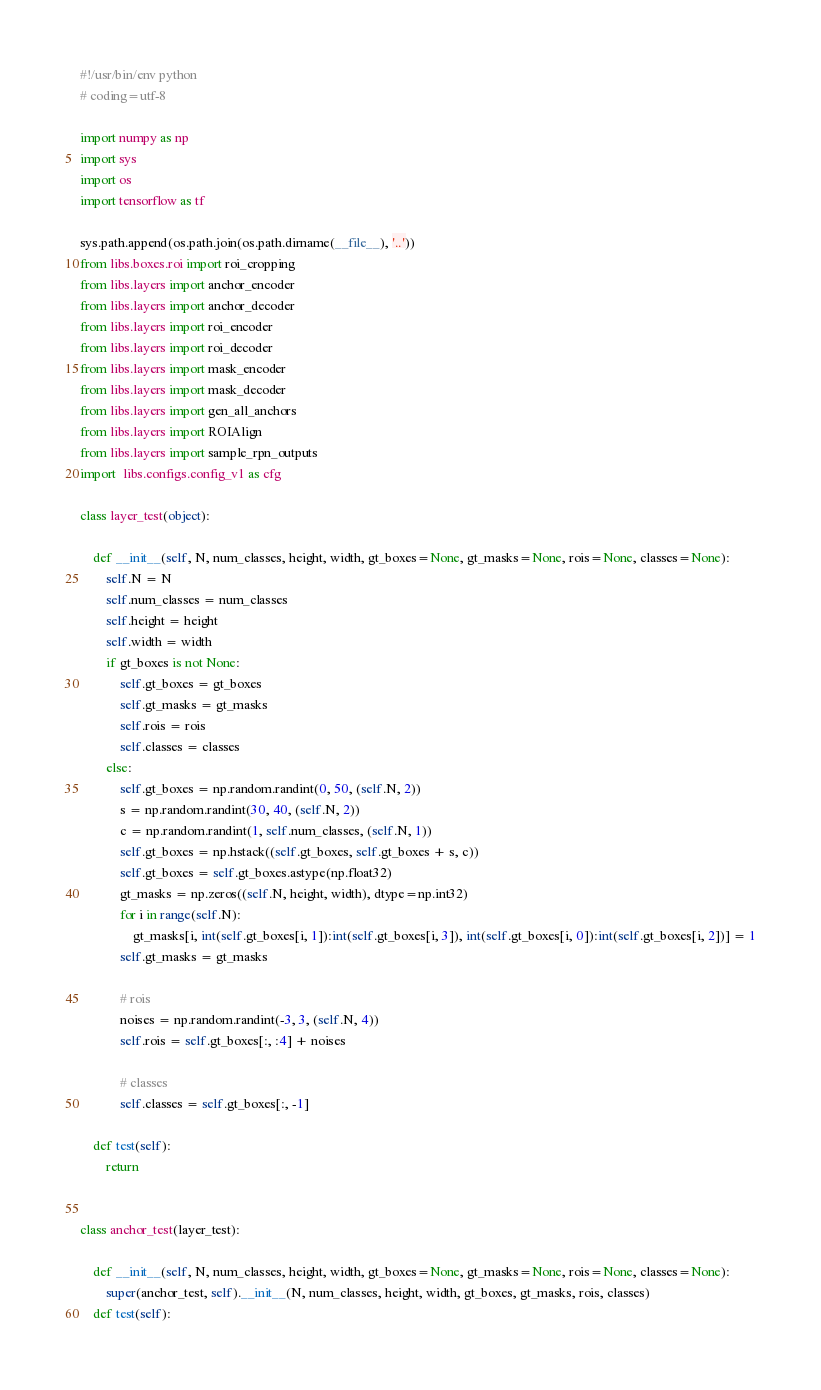<code> <loc_0><loc_0><loc_500><loc_500><_Python_>#!/usr/bin/env python 
# coding=utf-8

import numpy as np
import sys
import os
import tensorflow as tf 

sys.path.append(os.path.join(os.path.dirname(__file__), '..'))
from libs.boxes.roi import roi_cropping
from libs.layers import anchor_encoder
from libs.layers import anchor_decoder
from libs.layers import roi_encoder
from libs.layers import roi_decoder
from libs.layers import mask_encoder
from libs.layers import mask_decoder
from libs.layers import gen_all_anchors
from libs.layers import ROIAlign
from libs.layers import sample_rpn_outputs
import  libs.configs.config_v1 as cfg

class layer_test(object):

    def __init__(self, N, num_classes, height, width, gt_boxes=None, gt_masks=None, rois=None, classes=None):
        self.N = N
        self.num_classes = num_classes 
        self.height = height
        self.width = width 
        if gt_boxes is not None:
            self.gt_boxes = gt_boxes
            self.gt_masks = gt_masks 
            self.rois = rois 
            self.classes = classes
        else:
            self.gt_boxes = np.random.randint(0, 50, (self.N, 2))
            s = np.random.randint(30, 40, (self.N, 2))
            c = np.random.randint(1, self.num_classes, (self.N, 1))
            self.gt_boxes = np.hstack((self.gt_boxes, self.gt_boxes + s, c))
            self.gt_boxes = self.gt_boxes.astype(np.float32)
            gt_masks = np.zeros((self.N, height, width), dtype=np.int32)
            for i in range(self.N):
                gt_masks[i, int(self.gt_boxes[i, 1]):int(self.gt_boxes[i, 3]), int(self.gt_boxes[i, 0]):int(self.gt_boxes[i, 2])] = 1
            self.gt_masks = gt_masks

            # rois 
            noises = np.random.randint(-3, 3, (self.N, 4))
            self.rois = self.gt_boxes[:, :4] + noises 

            # classes 
            self.classes = self.gt_boxes[:, -1]

    def test(self):
        return


class anchor_test(layer_test):

    def __init__(self, N, num_classes, height, width, gt_boxes=None, gt_masks=None, rois=None, classes=None):
        super(anchor_test, self).__init__(N, num_classes, height, width, gt_boxes, gt_masks, rois, classes)
    def test(self):</code> 